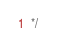Convert code to text. <code><loc_0><loc_0><loc_500><loc_500><_CSS_>*/</code> 